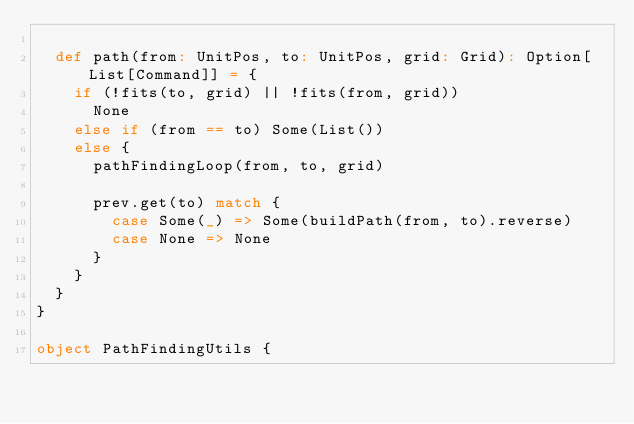<code> <loc_0><loc_0><loc_500><loc_500><_Scala_>
  def path(from: UnitPos, to: UnitPos, grid: Grid): Option[List[Command]] = {
    if (!fits(to, grid) || !fits(from, grid))
      None
    else if (from == to) Some(List())
    else {
      pathFindingLoop(from, to, grid)

      prev.get(to) match {
        case Some(_) => Some(buildPath(from, to).reverse)
        case None => None
      }
    }
  }
}

object PathFindingUtils {</code> 